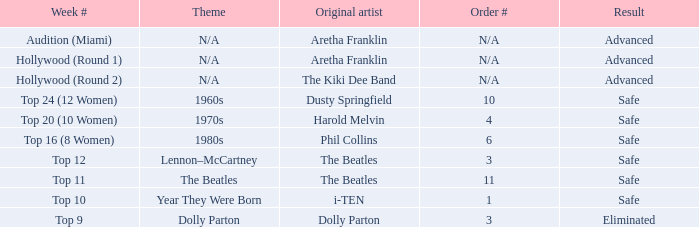Which original artist possesses the 11th position in order? The Beatles. 